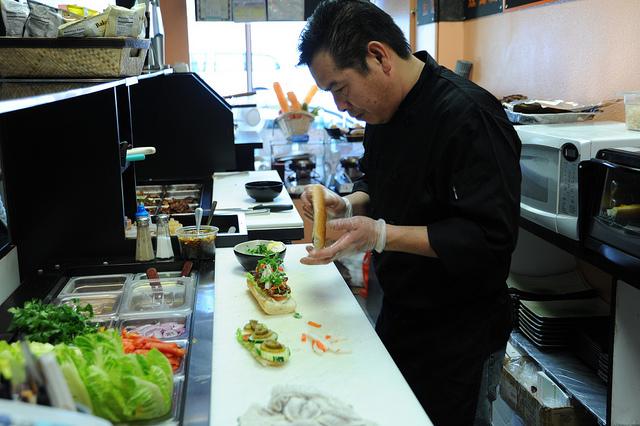Who is in the picture?
Write a very short answer. Chef. What are they cooking?
Give a very brief answer. Sandwiches. What food item is he making?
Short answer required. Sandwich. Is there salt and pepper on the counter?
Write a very short answer. Yes. 